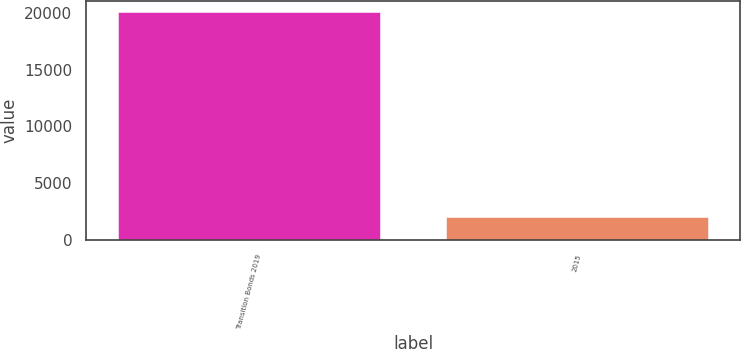Convert chart to OTSL. <chart><loc_0><loc_0><loc_500><loc_500><bar_chart><fcel>Transition Bonds 2019<fcel>2015<nl><fcel>20041<fcel>1995<nl></chart> 